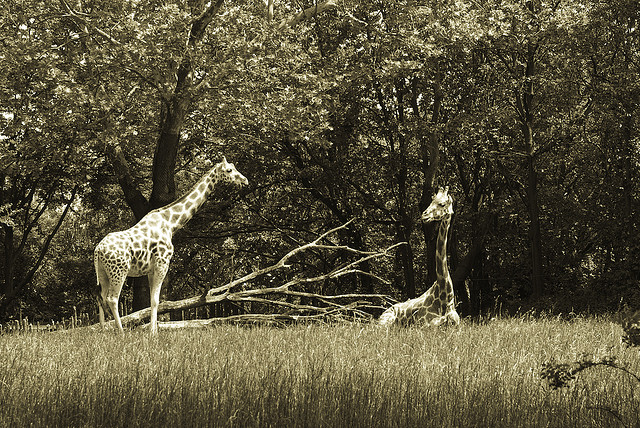<image>What animal is in the trees? I am not sure. The animal in the trees can be a bird, giraffe or there might not be an animal. What animal is in the trees? I am not sure what animal is in the trees. It can be seen giraffe or bird. 